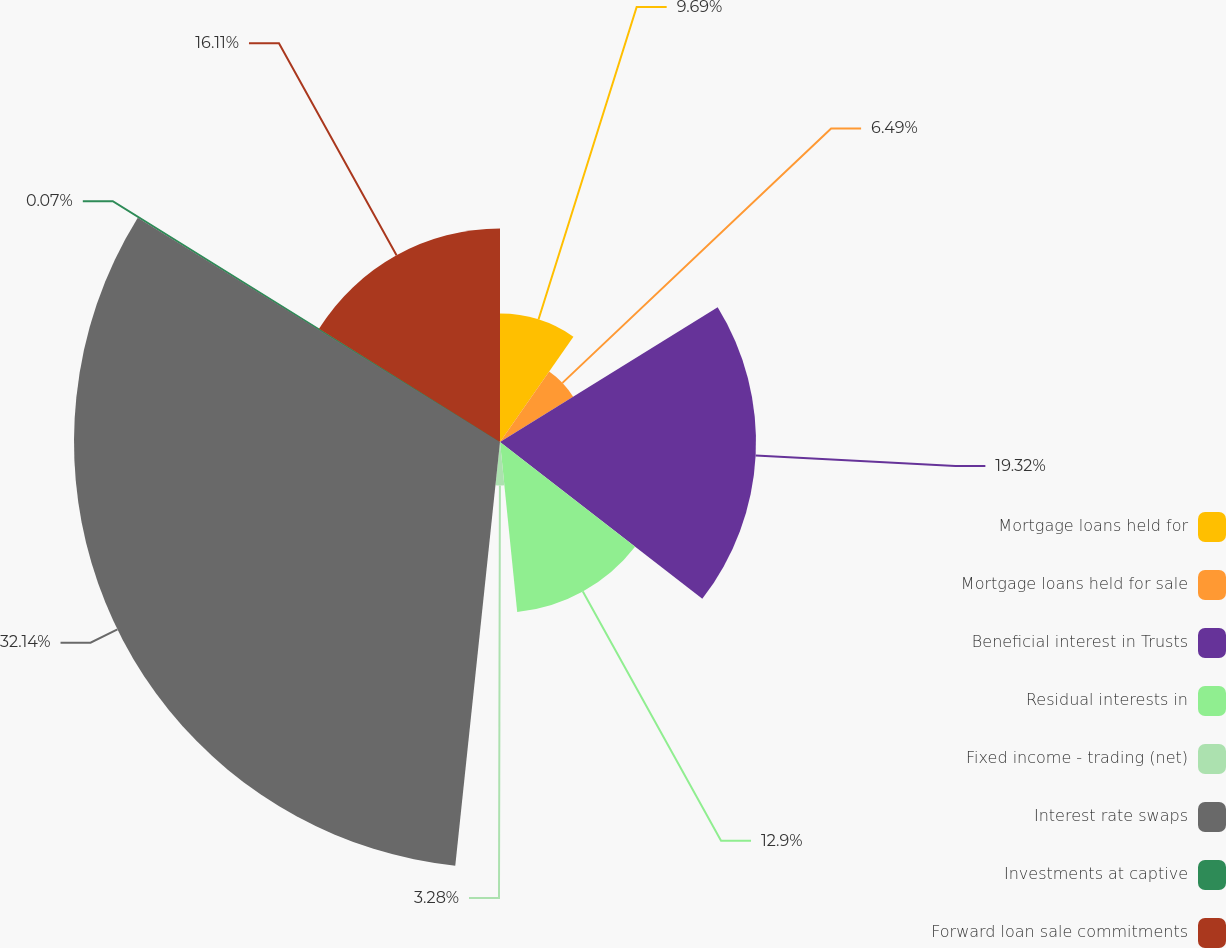Convert chart to OTSL. <chart><loc_0><loc_0><loc_500><loc_500><pie_chart><fcel>Mortgage loans held for<fcel>Mortgage loans held for sale<fcel>Beneficial interest in Trusts<fcel>Residual interests in<fcel>Fixed income - trading (net)<fcel>Interest rate swaps<fcel>Investments at captive<fcel>Forward loan sale commitments<nl><fcel>9.69%<fcel>6.49%<fcel>19.32%<fcel>12.9%<fcel>3.28%<fcel>32.15%<fcel>0.07%<fcel>16.11%<nl></chart> 